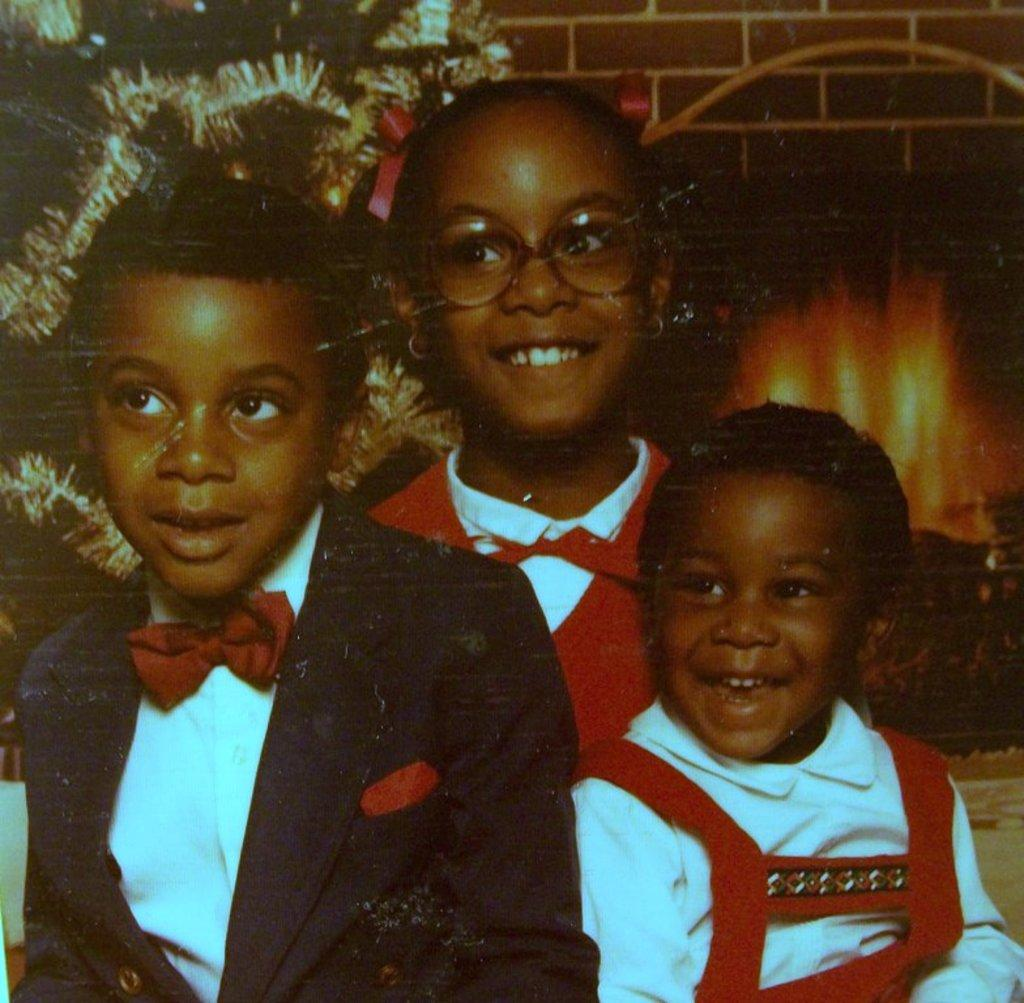How many kids are in the image? There are three kids in the image. What are the kids doing in the image? The kids are laughing. What can be seen in the background of the image? There is a Christmas tree, firewood, and a chimney in the background. What type of map is hanging on the wall in the image? There is no map present in the image. What type of education is being provided to the kids in the image? There is no indication of education being provided in the image; the kids are simply laughing. 